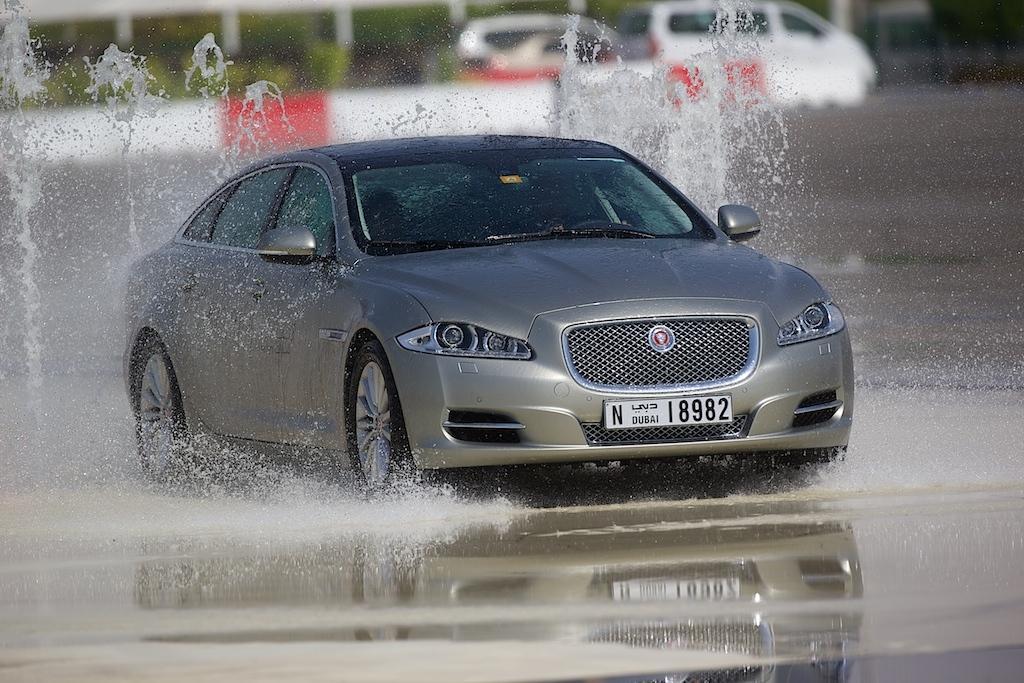How would you summarize this image in a sentence or two? In this image we can see a car on the ground. We can also see some water on the ground. On the backside we can see a fence, some vehicles on the ground, some poles and plants. 